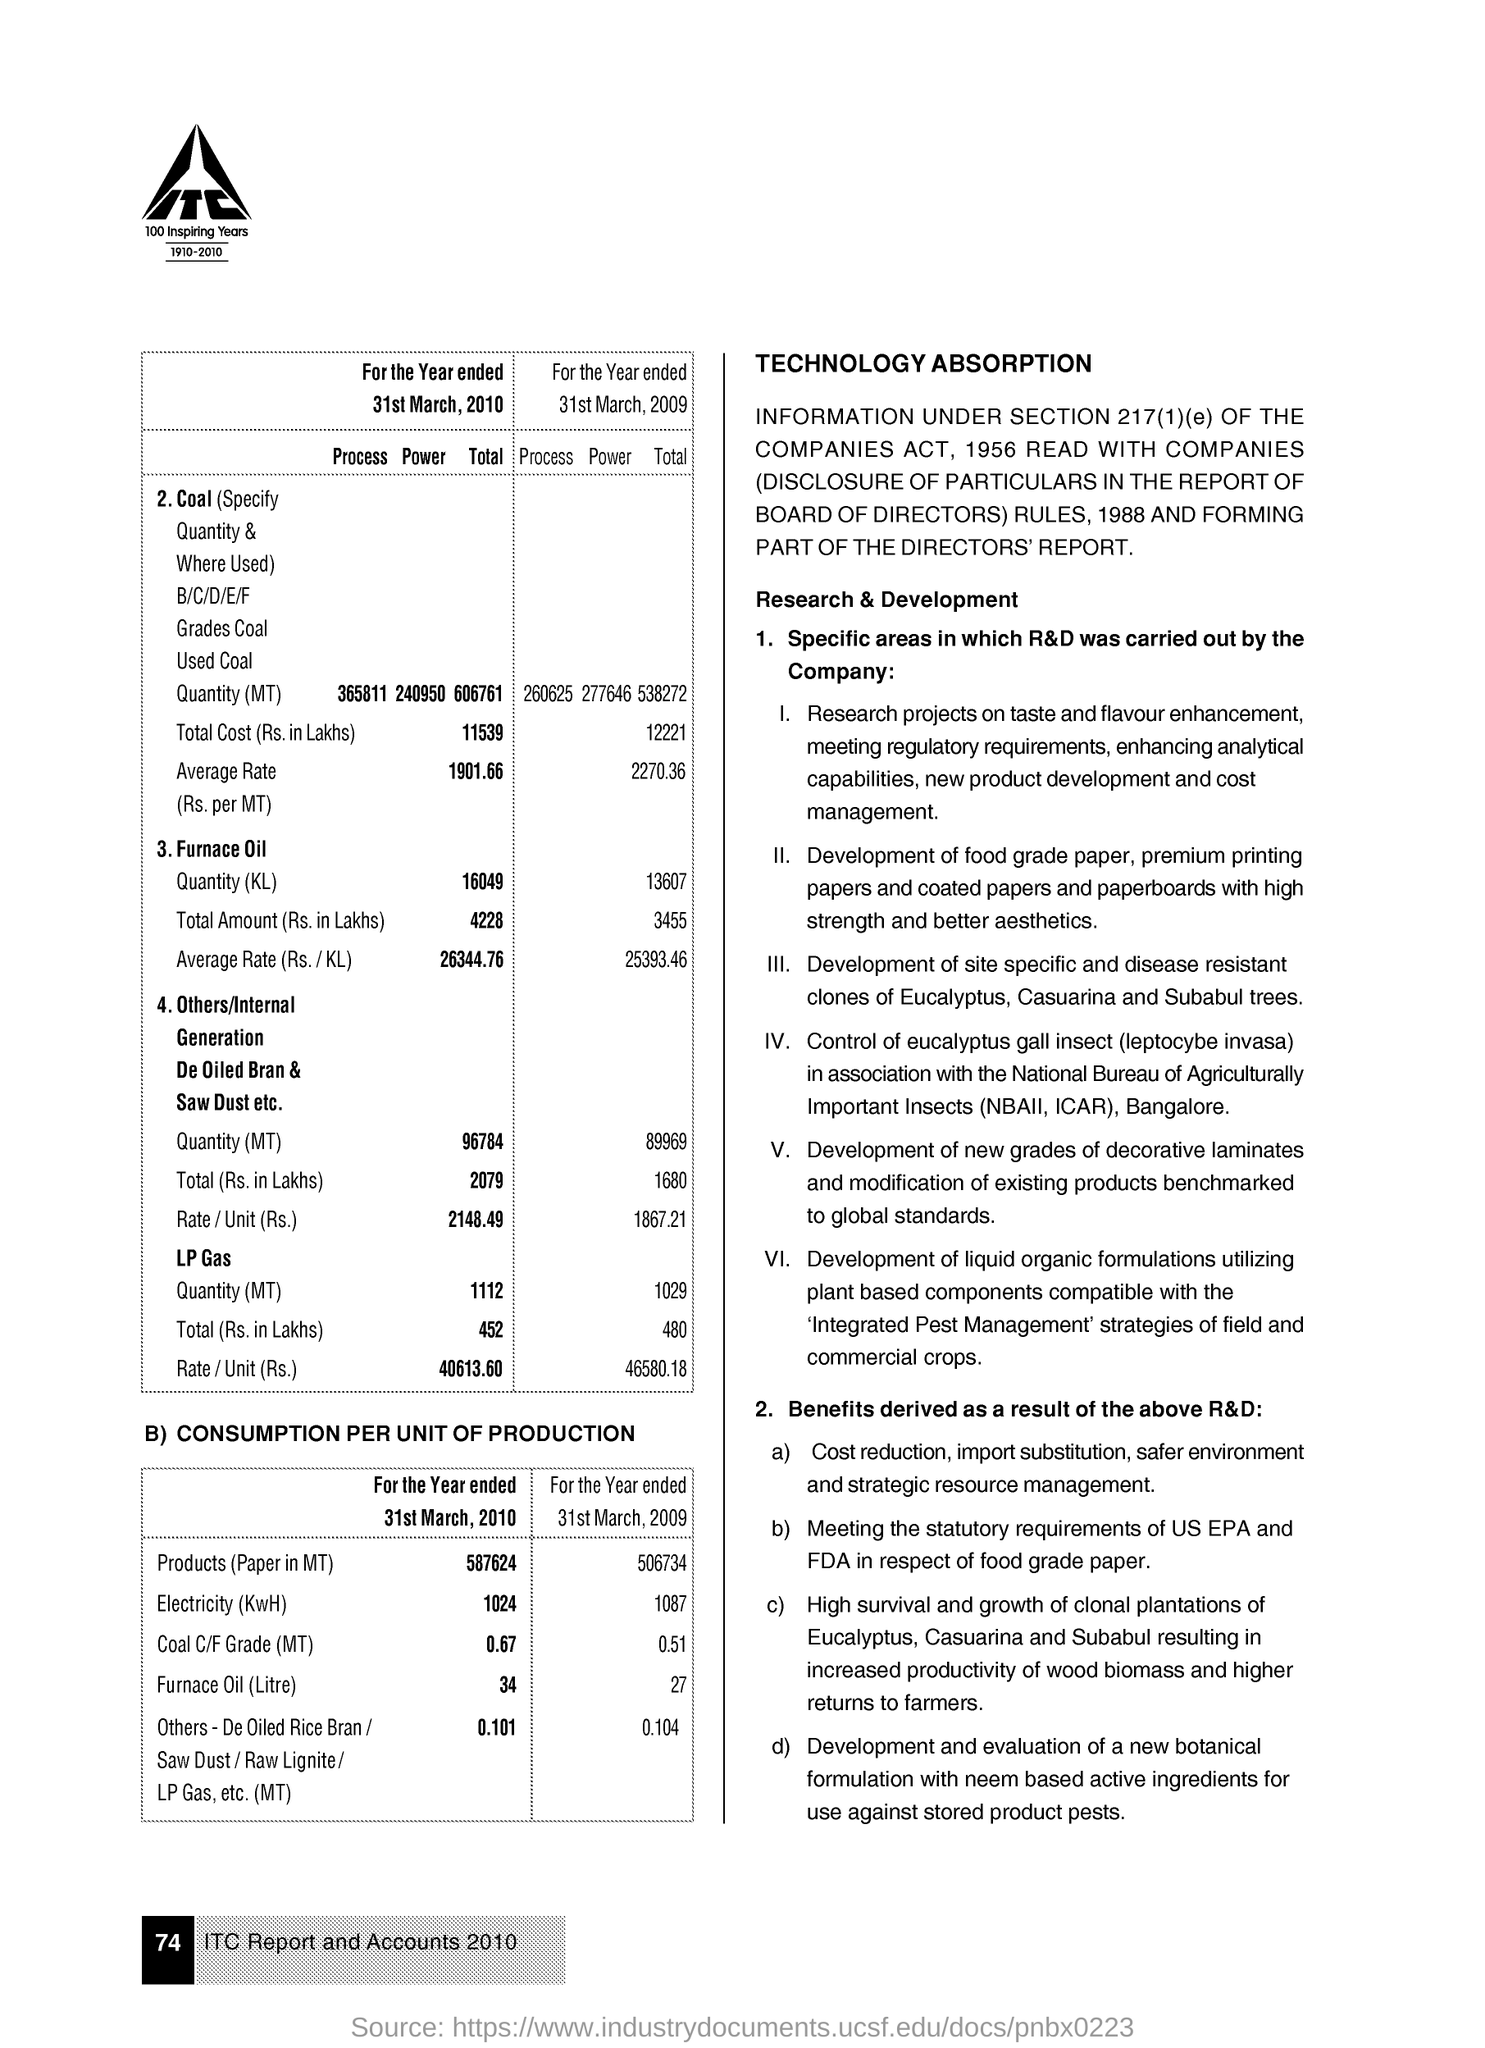What is the Electricity (KwH) for the Year ended 31st March, 2010?
Your answer should be compact. 1024. What is the Electricity (KwH) for the Year ended 31st March, 2009?
Make the answer very short. 1087. What is the Coal C/F Grade (MT) for the Year ended 31st March, 2010?
Ensure brevity in your answer.  0.67. What is the Coal C/F Grade (MT) for the Year ended 31st March, 2009?
Provide a succinct answer. 0.51. What is the Furnace Oil (Litre) for the Year ended 31st March, 2010?
Provide a succinct answer. 34. What is the Furnace Oil (Litre) for the Year ended 31st March, 2009?
Provide a succinct answer. 27. 